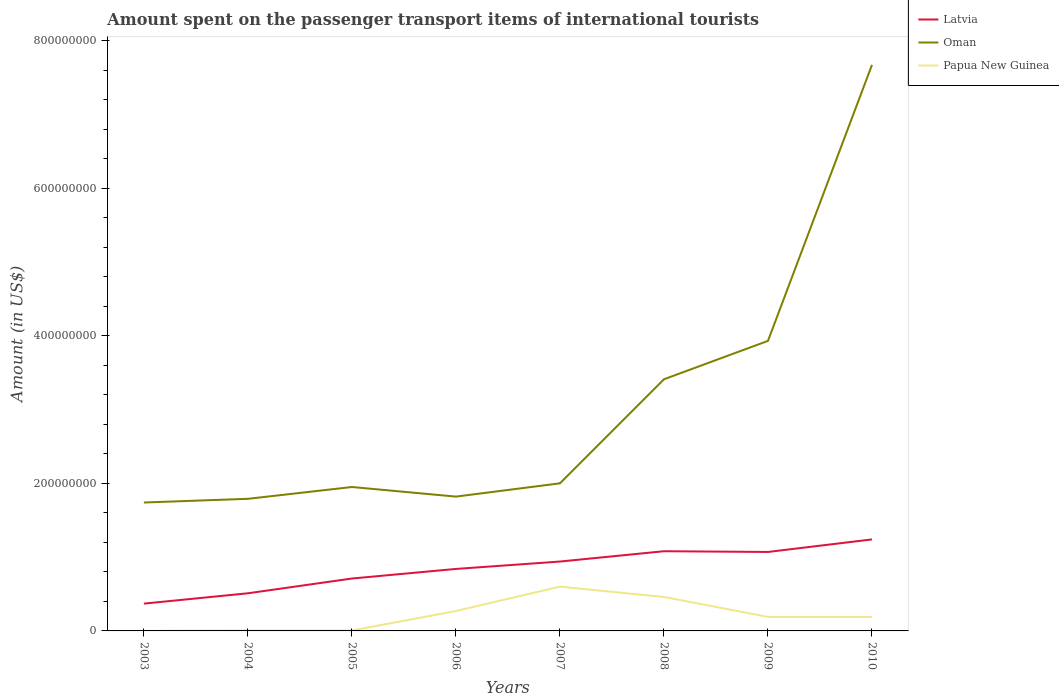Across all years, what is the maximum amount spent on the passenger transport items of international tourists in Latvia?
Offer a terse response. 3.70e+07. What is the total amount spent on the passenger transport items of international tourists in Latvia in the graph?
Provide a short and direct response. -4.30e+07. What is the difference between the highest and the second highest amount spent on the passenger transport items of international tourists in Oman?
Your answer should be very brief. 5.93e+08. Is the amount spent on the passenger transport items of international tourists in Latvia strictly greater than the amount spent on the passenger transport items of international tourists in Papua New Guinea over the years?
Your answer should be compact. No. How many lines are there?
Keep it short and to the point. 3. Where does the legend appear in the graph?
Your answer should be very brief. Top right. How are the legend labels stacked?
Give a very brief answer. Vertical. What is the title of the graph?
Your answer should be very brief. Amount spent on the passenger transport items of international tourists. Does "New Zealand" appear as one of the legend labels in the graph?
Provide a short and direct response. No. What is the label or title of the X-axis?
Ensure brevity in your answer.  Years. What is the label or title of the Y-axis?
Give a very brief answer. Amount (in US$). What is the Amount (in US$) in Latvia in 2003?
Ensure brevity in your answer.  3.70e+07. What is the Amount (in US$) of Oman in 2003?
Offer a very short reply. 1.74e+08. What is the Amount (in US$) of Latvia in 2004?
Your response must be concise. 5.10e+07. What is the Amount (in US$) of Oman in 2004?
Your answer should be compact. 1.79e+08. What is the Amount (in US$) in Papua New Guinea in 2004?
Your answer should be very brief. 7.00e+05. What is the Amount (in US$) in Latvia in 2005?
Make the answer very short. 7.10e+07. What is the Amount (in US$) in Oman in 2005?
Offer a very short reply. 1.95e+08. What is the Amount (in US$) of Latvia in 2006?
Your response must be concise. 8.40e+07. What is the Amount (in US$) in Oman in 2006?
Your answer should be compact. 1.82e+08. What is the Amount (in US$) in Papua New Guinea in 2006?
Provide a short and direct response. 2.70e+07. What is the Amount (in US$) of Latvia in 2007?
Your response must be concise. 9.40e+07. What is the Amount (in US$) in Papua New Guinea in 2007?
Give a very brief answer. 6.00e+07. What is the Amount (in US$) in Latvia in 2008?
Provide a short and direct response. 1.08e+08. What is the Amount (in US$) in Oman in 2008?
Keep it short and to the point. 3.41e+08. What is the Amount (in US$) of Papua New Guinea in 2008?
Offer a terse response. 4.60e+07. What is the Amount (in US$) in Latvia in 2009?
Give a very brief answer. 1.07e+08. What is the Amount (in US$) in Oman in 2009?
Your answer should be compact. 3.93e+08. What is the Amount (in US$) in Papua New Guinea in 2009?
Provide a short and direct response. 1.90e+07. What is the Amount (in US$) in Latvia in 2010?
Offer a very short reply. 1.24e+08. What is the Amount (in US$) in Oman in 2010?
Make the answer very short. 7.67e+08. What is the Amount (in US$) of Papua New Guinea in 2010?
Keep it short and to the point. 1.90e+07. Across all years, what is the maximum Amount (in US$) of Latvia?
Your answer should be very brief. 1.24e+08. Across all years, what is the maximum Amount (in US$) of Oman?
Keep it short and to the point. 7.67e+08. Across all years, what is the maximum Amount (in US$) in Papua New Guinea?
Provide a short and direct response. 6.00e+07. Across all years, what is the minimum Amount (in US$) in Latvia?
Make the answer very short. 3.70e+07. Across all years, what is the minimum Amount (in US$) of Oman?
Ensure brevity in your answer.  1.74e+08. What is the total Amount (in US$) in Latvia in the graph?
Your answer should be very brief. 6.76e+08. What is the total Amount (in US$) in Oman in the graph?
Provide a short and direct response. 2.43e+09. What is the total Amount (in US$) in Papua New Guinea in the graph?
Offer a very short reply. 1.72e+08. What is the difference between the Amount (in US$) of Latvia in 2003 and that in 2004?
Offer a very short reply. -1.40e+07. What is the difference between the Amount (in US$) of Oman in 2003 and that in 2004?
Keep it short and to the point. -5.00e+06. What is the difference between the Amount (in US$) in Papua New Guinea in 2003 and that in 2004?
Keep it short and to the point. -6.00e+05. What is the difference between the Amount (in US$) of Latvia in 2003 and that in 2005?
Your answer should be compact. -3.40e+07. What is the difference between the Amount (in US$) in Oman in 2003 and that in 2005?
Your response must be concise. -2.10e+07. What is the difference between the Amount (in US$) in Papua New Guinea in 2003 and that in 2005?
Offer a terse response. -5.00e+05. What is the difference between the Amount (in US$) of Latvia in 2003 and that in 2006?
Provide a succinct answer. -4.70e+07. What is the difference between the Amount (in US$) in Oman in 2003 and that in 2006?
Your response must be concise. -8.00e+06. What is the difference between the Amount (in US$) of Papua New Guinea in 2003 and that in 2006?
Ensure brevity in your answer.  -2.69e+07. What is the difference between the Amount (in US$) of Latvia in 2003 and that in 2007?
Provide a succinct answer. -5.70e+07. What is the difference between the Amount (in US$) in Oman in 2003 and that in 2007?
Provide a short and direct response. -2.60e+07. What is the difference between the Amount (in US$) in Papua New Guinea in 2003 and that in 2007?
Provide a short and direct response. -5.99e+07. What is the difference between the Amount (in US$) in Latvia in 2003 and that in 2008?
Give a very brief answer. -7.10e+07. What is the difference between the Amount (in US$) in Oman in 2003 and that in 2008?
Your response must be concise. -1.67e+08. What is the difference between the Amount (in US$) in Papua New Guinea in 2003 and that in 2008?
Your answer should be very brief. -4.59e+07. What is the difference between the Amount (in US$) in Latvia in 2003 and that in 2009?
Your answer should be compact. -7.00e+07. What is the difference between the Amount (in US$) in Oman in 2003 and that in 2009?
Ensure brevity in your answer.  -2.19e+08. What is the difference between the Amount (in US$) in Papua New Guinea in 2003 and that in 2009?
Your response must be concise. -1.89e+07. What is the difference between the Amount (in US$) in Latvia in 2003 and that in 2010?
Offer a terse response. -8.70e+07. What is the difference between the Amount (in US$) of Oman in 2003 and that in 2010?
Give a very brief answer. -5.93e+08. What is the difference between the Amount (in US$) in Papua New Guinea in 2003 and that in 2010?
Make the answer very short. -1.89e+07. What is the difference between the Amount (in US$) of Latvia in 2004 and that in 2005?
Give a very brief answer. -2.00e+07. What is the difference between the Amount (in US$) of Oman in 2004 and that in 2005?
Keep it short and to the point. -1.60e+07. What is the difference between the Amount (in US$) of Papua New Guinea in 2004 and that in 2005?
Your answer should be very brief. 1.00e+05. What is the difference between the Amount (in US$) of Latvia in 2004 and that in 2006?
Ensure brevity in your answer.  -3.30e+07. What is the difference between the Amount (in US$) of Oman in 2004 and that in 2006?
Your answer should be compact. -3.00e+06. What is the difference between the Amount (in US$) of Papua New Guinea in 2004 and that in 2006?
Your answer should be compact. -2.63e+07. What is the difference between the Amount (in US$) of Latvia in 2004 and that in 2007?
Ensure brevity in your answer.  -4.30e+07. What is the difference between the Amount (in US$) of Oman in 2004 and that in 2007?
Keep it short and to the point. -2.10e+07. What is the difference between the Amount (in US$) in Papua New Guinea in 2004 and that in 2007?
Offer a terse response. -5.93e+07. What is the difference between the Amount (in US$) of Latvia in 2004 and that in 2008?
Provide a succinct answer. -5.70e+07. What is the difference between the Amount (in US$) in Oman in 2004 and that in 2008?
Ensure brevity in your answer.  -1.62e+08. What is the difference between the Amount (in US$) in Papua New Guinea in 2004 and that in 2008?
Keep it short and to the point. -4.53e+07. What is the difference between the Amount (in US$) in Latvia in 2004 and that in 2009?
Offer a very short reply. -5.60e+07. What is the difference between the Amount (in US$) in Oman in 2004 and that in 2009?
Offer a very short reply. -2.14e+08. What is the difference between the Amount (in US$) in Papua New Guinea in 2004 and that in 2009?
Your answer should be very brief. -1.83e+07. What is the difference between the Amount (in US$) in Latvia in 2004 and that in 2010?
Provide a succinct answer. -7.30e+07. What is the difference between the Amount (in US$) in Oman in 2004 and that in 2010?
Keep it short and to the point. -5.88e+08. What is the difference between the Amount (in US$) of Papua New Guinea in 2004 and that in 2010?
Give a very brief answer. -1.83e+07. What is the difference between the Amount (in US$) of Latvia in 2005 and that in 2006?
Keep it short and to the point. -1.30e+07. What is the difference between the Amount (in US$) in Oman in 2005 and that in 2006?
Your response must be concise. 1.30e+07. What is the difference between the Amount (in US$) in Papua New Guinea in 2005 and that in 2006?
Give a very brief answer. -2.64e+07. What is the difference between the Amount (in US$) of Latvia in 2005 and that in 2007?
Provide a short and direct response. -2.30e+07. What is the difference between the Amount (in US$) in Oman in 2005 and that in 2007?
Keep it short and to the point. -5.00e+06. What is the difference between the Amount (in US$) of Papua New Guinea in 2005 and that in 2007?
Provide a short and direct response. -5.94e+07. What is the difference between the Amount (in US$) in Latvia in 2005 and that in 2008?
Give a very brief answer. -3.70e+07. What is the difference between the Amount (in US$) in Oman in 2005 and that in 2008?
Make the answer very short. -1.46e+08. What is the difference between the Amount (in US$) of Papua New Guinea in 2005 and that in 2008?
Give a very brief answer. -4.54e+07. What is the difference between the Amount (in US$) of Latvia in 2005 and that in 2009?
Offer a terse response. -3.60e+07. What is the difference between the Amount (in US$) of Oman in 2005 and that in 2009?
Make the answer very short. -1.98e+08. What is the difference between the Amount (in US$) in Papua New Guinea in 2005 and that in 2009?
Give a very brief answer. -1.84e+07. What is the difference between the Amount (in US$) of Latvia in 2005 and that in 2010?
Offer a terse response. -5.30e+07. What is the difference between the Amount (in US$) in Oman in 2005 and that in 2010?
Offer a very short reply. -5.72e+08. What is the difference between the Amount (in US$) in Papua New Guinea in 2005 and that in 2010?
Give a very brief answer. -1.84e+07. What is the difference between the Amount (in US$) of Latvia in 2006 and that in 2007?
Offer a terse response. -1.00e+07. What is the difference between the Amount (in US$) in Oman in 2006 and that in 2007?
Give a very brief answer. -1.80e+07. What is the difference between the Amount (in US$) of Papua New Guinea in 2006 and that in 2007?
Keep it short and to the point. -3.30e+07. What is the difference between the Amount (in US$) of Latvia in 2006 and that in 2008?
Make the answer very short. -2.40e+07. What is the difference between the Amount (in US$) of Oman in 2006 and that in 2008?
Provide a short and direct response. -1.59e+08. What is the difference between the Amount (in US$) in Papua New Guinea in 2006 and that in 2008?
Provide a succinct answer. -1.90e+07. What is the difference between the Amount (in US$) in Latvia in 2006 and that in 2009?
Ensure brevity in your answer.  -2.30e+07. What is the difference between the Amount (in US$) in Oman in 2006 and that in 2009?
Offer a very short reply. -2.11e+08. What is the difference between the Amount (in US$) of Papua New Guinea in 2006 and that in 2009?
Your response must be concise. 8.00e+06. What is the difference between the Amount (in US$) in Latvia in 2006 and that in 2010?
Keep it short and to the point. -4.00e+07. What is the difference between the Amount (in US$) in Oman in 2006 and that in 2010?
Make the answer very short. -5.85e+08. What is the difference between the Amount (in US$) of Latvia in 2007 and that in 2008?
Provide a short and direct response. -1.40e+07. What is the difference between the Amount (in US$) of Oman in 2007 and that in 2008?
Make the answer very short. -1.41e+08. What is the difference between the Amount (in US$) of Papua New Guinea in 2007 and that in 2008?
Provide a succinct answer. 1.40e+07. What is the difference between the Amount (in US$) in Latvia in 2007 and that in 2009?
Provide a succinct answer. -1.30e+07. What is the difference between the Amount (in US$) of Oman in 2007 and that in 2009?
Your response must be concise. -1.93e+08. What is the difference between the Amount (in US$) of Papua New Guinea in 2007 and that in 2009?
Keep it short and to the point. 4.10e+07. What is the difference between the Amount (in US$) in Latvia in 2007 and that in 2010?
Offer a terse response. -3.00e+07. What is the difference between the Amount (in US$) in Oman in 2007 and that in 2010?
Your answer should be very brief. -5.67e+08. What is the difference between the Amount (in US$) of Papua New Guinea in 2007 and that in 2010?
Give a very brief answer. 4.10e+07. What is the difference between the Amount (in US$) in Oman in 2008 and that in 2009?
Give a very brief answer. -5.20e+07. What is the difference between the Amount (in US$) of Papua New Guinea in 2008 and that in 2009?
Offer a very short reply. 2.70e+07. What is the difference between the Amount (in US$) in Latvia in 2008 and that in 2010?
Ensure brevity in your answer.  -1.60e+07. What is the difference between the Amount (in US$) in Oman in 2008 and that in 2010?
Your response must be concise. -4.26e+08. What is the difference between the Amount (in US$) in Papua New Guinea in 2008 and that in 2010?
Your response must be concise. 2.70e+07. What is the difference between the Amount (in US$) of Latvia in 2009 and that in 2010?
Keep it short and to the point. -1.70e+07. What is the difference between the Amount (in US$) of Oman in 2009 and that in 2010?
Offer a terse response. -3.74e+08. What is the difference between the Amount (in US$) of Latvia in 2003 and the Amount (in US$) of Oman in 2004?
Make the answer very short. -1.42e+08. What is the difference between the Amount (in US$) in Latvia in 2003 and the Amount (in US$) in Papua New Guinea in 2004?
Provide a succinct answer. 3.63e+07. What is the difference between the Amount (in US$) in Oman in 2003 and the Amount (in US$) in Papua New Guinea in 2004?
Your answer should be very brief. 1.73e+08. What is the difference between the Amount (in US$) of Latvia in 2003 and the Amount (in US$) of Oman in 2005?
Provide a succinct answer. -1.58e+08. What is the difference between the Amount (in US$) in Latvia in 2003 and the Amount (in US$) in Papua New Guinea in 2005?
Provide a succinct answer. 3.64e+07. What is the difference between the Amount (in US$) of Oman in 2003 and the Amount (in US$) of Papua New Guinea in 2005?
Keep it short and to the point. 1.73e+08. What is the difference between the Amount (in US$) in Latvia in 2003 and the Amount (in US$) in Oman in 2006?
Give a very brief answer. -1.45e+08. What is the difference between the Amount (in US$) in Oman in 2003 and the Amount (in US$) in Papua New Guinea in 2006?
Your answer should be compact. 1.47e+08. What is the difference between the Amount (in US$) of Latvia in 2003 and the Amount (in US$) of Oman in 2007?
Your answer should be very brief. -1.63e+08. What is the difference between the Amount (in US$) in Latvia in 2003 and the Amount (in US$) in Papua New Guinea in 2007?
Keep it short and to the point. -2.30e+07. What is the difference between the Amount (in US$) of Oman in 2003 and the Amount (in US$) of Papua New Guinea in 2007?
Provide a short and direct response. 1.14e+08. What is the difference between the Amount (in US$) of Latvia in 2003 and the Amount (in US$) of Oman in 2008?
Provide a short and direct response. -3.04e+08. What is the difference between the Amount (in US$) in Latvia in 2003 and the Amount (in US$) in Papua New Guinea in 2008?
Offer a terse response. -9.00e+06. What is the difference between the Amount (in US$) of Oman in 2003 and the Amount (in US$) of Papua New Guinea in 2008?
Offer a very short reply. 1.28e+08. What is the difference between the Amount (in US$) of Latvia in 2003 and the Amount (in US$) of Oman in 2009?
Offer a terse response. -3.56e+08. What is the difference between the Amount (in US$) in Latvia in 2003 and the Amount (in US$) in Papua New Guinea in 2009?
Your answer should be compact. 1.80e+07. What is the difference between the Amount (in US$) in Oman in 2003 and the Amount (in US$) in Papua New Guinea in 2009?
Ensure brevity in your answer.  1.55e+08. What is the difference between the Amount (in US$) of Latvia in 2003 and the Amount (in US$) of Oman in 2010?
Ensure brevity in your answer.  -7.30e+08. What is the difference between the Amount (in US$) of Latvia in 2003 and the Amount (in US$) of Papua New Guinea in 2010?
Your response must be concise. 1.80e+07. What is the difference between the Amount (in US$) in Oman in 2003 and the Amount (in US$) in Papua New Guinea in 2010?
Give a very brief answer. 1.55e+08. What is the difference between the Amount (in US$) in Latvia in 2004 and the Amount (in US$) in Oman in 2005?
Provide a short and direct response. -1.44e+08. What is the difference between the Amount (in US$) in Latvia in 2004 and the Amount (in US$) in Papua New Guinea in 2005?
Provide a succinct answer. 5.04e+07. What is the difference between the Amount (in US$) of Oman in 2004 and the Amount (in US$) of Papua New Guinea in 2005?
Ensure brevity in your answer.  1.78e+08. What is the difference between the Amount (in US$) in Latvia in 2004 and the Amount (in US$) in Oman in 2006?
Offer a terse response. -1.31e+08. What is the difference between the Amount (in US$) in Latvia in 2004 and the Amount (in US$) in Papua New Guinea in 2006?
Keep it short and to the point. 2.40e+07. What is the difference between the Amount (in US$) in Oman in 2004 and the Amount (in US$) in Papua New Guinea in 2006?
Provide a short and direct response. 1.52e+08. What is the difference between the Amount (in US$) in Latvia in 2004 and the Amount (in US$) in Oman in 2007?
Your answer should be compact. -1.49e+08. What is the difference between the Amount (in US$) in Latvia in 2004 and the Amount (in US$) in Papua New Guinea in 2007?
Provide a succinct answer. -9.00e+06. What is the difference between the Amount (in US$) of Oman in 2004 and the Amount (in US$) of Papua New Guinea in 2007?
Provide a succinct answer. 1.19e+08. What is the difference between the Amount (in US$) of Latvia in 2004 and the Amount (in US$) of Oman in 2008?
Provide a short and direct response. -2.90e+08. What is the difference between the Amount (in US$) of Oman in 2004 and the Amount (in US$) of Papua New Guinea in 2008?
Provide a succinct answer. 1.33e+08. What is the difference between the Amount (in US$) of Latvia in 2004 and the Amount (in US$) of Oman in 2009?
Offer a very short reply. -3.42e+08. What is the difference between the Amount (in US$) in Latvia in 2004 and the Amount (in US$) in Papua New Guinea in 2009?
Keep it short and to the point. 3.20e+07. What is the difference between the Amount (in US$) in Oman in 2004 and the Amount (in US$) in Papua New Guinea in 2009?
Your answer should be very brief. 1.60e+08. What is the difference between the Amount (in US$) in Latvia in 2004 and the Amount (in US$) in Oman in 2010?
Offer a very short reply. -7.16e+08. What is the difference between the Amount (in US$) in Latvia in 2004 and the Amount (in US$) in Papua New Guinea in 2010?
Your answer should be very brief. 3.20e+07. What is the difference between the Amount (in US$) of Oman in 2004 and the Amount (in US$) of Papua New Guinea in 2010?
Offer a very short reply. 1.60e+08. What is the difference between the Amount (in US$) of Latvia in 2005 and the Amount (in US$) of Oman in 2006?
Offer a very short reply. -1.11e+08. What is the difference between the Amount (in US$) of Latvia in 2005 and the Amount (in US$) of Papua New Guinea in 2006?
Provide a short and direct response. 4.40e+07. What is the difference between the Amount (in US$) in Oman in 2005 and the Amount (in US$) in Papua New Guinea in 2006?
Provide a short and direct response. 1.68e+08. What is the difference between the Amount (in US$) in Latvia in 2005 and the Amount (in US$) in Oman in 2007?
Your answer should be very brief. -1.29e+08. What is the difference between the Amount (in US$) of Latvia in 2005 and the Amount (in US$) of Papua New Guinea in 2007?
Your answer should be very brief. 1.10e+07. What is the difference between the Amount (in US$) of Oman in 2005 and the Amount (in US$) of Papua New Guinea in 2007?
Keep it short and to the point. 1.35e+08. What is the difference between the Amount (in US$) of Latvia in 2005 and the Amount (in US$) of Oman in 2008?
Make the answer very short. -2.70e+08. What is the difference between the Amount (in US$) in Latvia in 2005 and the Amount (in US$) in Papua New Guinea in 2008?
Offer a terse response. 2.50e+07. What is the difference between the Amount (in US$) of Oman in 2005 and the Amount (in US$) of Papua New Guinea in 2008?
Make the answer very short. 1.49e+08. What is the difference between the Amount (in US$) in Latvia in 2005 and the Amount (in US$) in Oman in 2009?
Ensure brevity in your answer.  -3.22e+08. What is the difference between the Amount (in US$) of Latvia in 2005 and the Amount (in US$) of Papua New Guinea in 2009?
Make the answer very short. 5.20e+07. What is the difference between the Amount (in US$) of Oman in 2005 and the Amount (in US$) of Papua New Guinea in 2009?
Provide a succinct answer. 1.76e+08. What is the difference between the Amount (in US$) in Latvia in 2005 and the Amount (in US$) in Oman in 2010?
Give a very brief answer. -6.96e+08. What is the difference between the Amount (in US$) of Latvia in 2005 and the Amount (in US$) of Papua New Guinea in 2010?
Provide a succinct answer. 5.20e+07. What is the difference between the Amount (in US$) in Oman in 2005 and the Amount (in US$) in Papua New Guinea in 2010?
Offer a terse response. 1.76e+08. What is the difference between the Amount (in US$) in Latvia in 2006 and the Amount (in US$) in Oman in 2007?
Your response must be concise. -1.16e+08. What is the difference between the Amount (in US$) of Latvia in 2006 and the Amount (in US$) of Papua New Guinea in 2007?
Offer a very short reply. 2.40e+07. What is the difference between the Amount (in US$) of Oman in 2006 and the Amount (in US$) of Papua New Guinea in 2007?
Ensure brevity in your answer.  1.22e+08. What is the difference between the Amount (in US$) of Latvia in 2006 and the Amount (in US$) of Oman in 2008?
Ensure brevity in your answer.  -2.57e+08. What is the difference between the Amount (in US$) of Latvia in 2006 and the Amount (in US$) of Papua New Guinea in 2008?
Keep it short and to the point. 3.80e+07. What is the difference between the Amount (in US$) in Oman in 2006 and the Amount (in US$) in Papua New Guinea in 2008?
Provide a succinct answer. 1.36e+08. What is the difference between the Amount (in US$) in Latvia in 2006 and the Amount (in US$) in Oman in 2009?
Your answer should be compact. -3.09e+08. What is the difference between the Amount (in US$) in Latvia in 2006 and the Amount (in US$) in Papua New Guinea in 2009?
Make the answer very short. 6.50e+07. What is the difference between the Amount (in US$) of Oman in 2006 and the Amount (in US$) of Papua New Guinea in 2009?
Ensure brevity in your answer.  1.63e+08. What is the difference between the Amount (in US$) in Latvia in 2006 and the Amount (in US$) in Oman in 2010?
Keep it short and to the point. -6.83e+08. What is the difference between the Amount (in US$) in Latvia in 2006 and the Amount (in US$) in Papua New Guinea in 2010?
Give a very brief answer. 6.50e+07. What is the difference between the Amount (in US$) in Oman in 2006 and the Amount (in US$) in Papua New Guinea in 2010?
Offer a very short reply. 1.63e+08. What is the difference between the Amount (in US$) of Latvia in 2007 and the Amount (in US$) of Oman in 2008?
Your answer should be very brief. -2.47e+08. What is the difference between the Amount (in US$) of Latvia in 2007 and the Amount (in US$) of Papua New Guinea in 2008?
Offer a very short reply. 4.80e+07. What is the difference between the Amount (in US$) of Oman in 2007 and the Amount (in US$) of Papua New Guinea in 2008?
Your answer should be compact. 1.54e+08. What is the difference between the Amount (in US$) in Latvia in 2007 and the Amount (in US$) in Oman in 2009?
Provide a short and direct response. -2.99e+08. What is the difference between the Amount (in US$) in Latvia in 2007 and the Amount (in US$) in Papua New Guinea in 2009?
Ensure brevity in your answer.  7.50e+07. What is the difference between the Amount (in US$) in Oman in 2007 and the Amount (in US$) in Papua New Guinea in 2009?
Your response must be concise. 1.81e+08. What is the difference between the Amount (in US$) in Latvia in 2007 and the Amount (in US$) in Oman in 2010?
Provide a succinct answer. -6.73e+08. What is the difference between the Amount (in US$) in Latvia in 2007 and the Amount (in US$) in Papua New Guinea in 2010?
Provide a succinct answer. 7.50e+07. What is the difference between the Amount (in US$) in Oman in 2007 and the Amount (in US$) in Papua New Guinea in 2010?
Offer a very short reply. 1.81e+08. What is the difference between the Amount (in US$) in Latvia in 2008 and the Amount (in US$) in Oman in 2009?
Your response must be concise. -2.85e+08. What is the difference between the Amount (in US$) in Latvia in 2008 and the Amount (in US$) in Papua New Guinea in 2009?
Keep it short and to the point. 8.90e+07. What is the difference between the Amount (in US$) in Oman in 2008 and the Amount (in US$) in Papua New Guinea in 2009?
Offer a terse response. 3.22e+08. What is the difference between the Amount (in US$) of Latvia in 2008 and the Amount (in US$) of Oman in 2010?
Your response must be concise. -6.59e+08. What is the difference between the Amount (in US$) in Latvia in 2008 and the Amount (in US$) in Papua New Guinea in 2010?
Ensure brevity in your answer.  8.90e+07. What is the difference between the Amount (in US$) of Oman in 2008 and the Amount (in US$) of Papua New Guinea in 2010?
Ensure brevity in your answer.  3.22e+08. What is the difference between the Amount (in US$) in Latvia in 2009 and the Amount (in US$) in Oman in 2010?
Provide a succinct answer. -6.60e+08. What is the difference between the Amount (in US$) of Latvia in 2009 and the Amount (in US$) of Papua New Guinea in 2010?
Provide a succinct answer. 8.80e+07. What is the difference between the Amount (in US$) of Oman in 2009 and the Amount (in US$) of Papua New Guinea in 2010?
Offer a terse response. 3.74e+08. What is the average Amount (in US$) of Latvia per year?
Give a very brief answer. 8.45e+07. What is the average Amount (in US$) of Oman per year?
Your answer should be compact. 3.04e+08. What is the average Amount (in US$) of Papua New Guinea per year?
Offer a terse response. 2.16e+07. In the year 2003, what is the difference between the Amount (in US$) in Latvia and Amount (in US$) in Oman?
Your answer should be very brief. -1.37e+08. In the year 2003, what is the difference between the Amount (in US$) of Latvia and Amount (in US$) of Papua New Guinea?
Offer a terse response. 3.69e+07. In the year 2003, what is the difference between the Amount (in US$) in Oman and Amount (in US$) in Papua New Guinea?
Offer a terse response. 1.74e+08. In the year 2004, what is the difference between the Amount (in US$) of Latvia and Amount (in US$) of Oman?
Keep it short and to the point. -1.28e+08. In the year 2004, what is the difference between the Amount (in US$) in Latvia and Amount (in US$) in Papua New Guinea?
Offer a very short reply. 5.03e+07. In the year 2004, what is the difference between the Amount (in US$) in Oman and Amount (in US$) in Papua New Guinea?
Keep it short and to the point. 1.78e+08. In the year 2005, what is the difference between the Amount (in US$) in Latvia and Amount (in US$) in Oman?
Your answer should be compact. -1.24e+08. In the year 2005, what is the difference between the Amount (in US$) of Latvia and Amount (in US$) of Papua New Guinea?
Make the answer very short. 7.04e+07. In the year 2005, what is the difference between the Amount (in US$) of Oman and Amount (in US$) of Papua New Guinea?
Provide a short and direct response. 1.94e+08. In the year 2006, what is the difference between the Amount (in US$) in Latvia and Amount (in US$) in Oman?
Offer a terse response. -9.80e+07. In the year 2006, what is the difference between the Amount (in US$) of Latvia and Amount (in US$) of Papua New Guinea?
Provide a short and direct response. 5.70e+07. In the year 2006, what is the difference between the Amount (in US$) of Oman and Amount (in US$) of Papua New Guinea?
Your answer should be very brief. 1.55e+08. In the year 2007, what is the difference between the Amount (in US$) in Latvia and Amount (in US$) in Oman?
Your answer should be very brief. -1.06e+08. In the year 2007, what is the difference between the Amount (in US$) in Latvia and Amount (in US$) in Papua New Guinea?
Give a very brief answer. 3.40e+07. In the year 2007, what is the difference between the Amount (in US$) in Oman and Amount (in US$) in Papua New Guinea?
Provide a short and direct response. 1.40e+08. In the year 2008, what is the difference between the Amount (in US$) in Latvia and Amount (in US$) in Oman?
Your answer should be compact. -2.33e+08. In the year 2008, what is the difference between the Amount (in US$) in Latvia and Amount (in US$) in Papua New Guinea?
Keep it short and to the point. 6.20e+07. In the year 2008, what is the difference between the Amount (in US$) of Oman and Amount (in US$) of Papua New Guinea?
Provide a short and direct response. 2.95e+08. In the year 2009, what is the difference between the Amount (in US$) in Latvia and Amount (in US$) in Oman?
Give a very brief answer. -2.86e+08. In the year 2009, what is the difference between the Amount (in US$) in Latvia and Amount (in US$) in Papua New Guinea?
Provide a succinct answer. 8.80e+07. In the year 2009, what is the difference between the Amount (in US$) in Oman and Amount (in US$) in Papua New Guinea?
Provide a succinct answer. 3.74e+08. In the year 2010, what is the difference between the Amount (in US$) in Latvia and Amount (in US$) in Oman?
Your answer should be compact. -6.43e+08. In the year 2010, what is the difference between the Amount (in US$) in Latvia and Amount (in US$) in Papua New Guinea?
Provide a succinct answer. 1.05e+08. In the year 2010, what is the difference between the Amount (in US$) in Oman and Amount (in US$) in Papua New Guinea?
Your answer should be compact. 7.48e+08. What is the ratio of the Amount (in US$) of Latvia in 2003 to that in 2004?
Your answer should be compact. 0.73. What is the ratio of the Amount (in US$) of Oman in 2003 to that in 2004?
Offer a terse response. 0.97. What is the ratio of the Amount (in US$) in Papua New Guinea in 2003 to that in 2004?
Offer a terse response. 0.14. What is the ratio of the Amount (in US$) in Latvia in 2003 to that in 2005?
Offer a very short reply. 0.52. What is the ratio of the Amount (in US$) of Oman in 2003 to that in 2005?
Your answer should be compact. 0.89. What is the ratio of the Amount (in US$) of Latvia in 2003 to that in 2006?
Offer a terse response. 0.44. What is the ratio of the Amount (in US$) of Oman in 2003 to that in 2006?
Give a very brief answer. 0.96. What is the ratio of the Amount (in US$) in Papua New Guinea in 2003 to that in 2006?
Give a very brief answer. 0. What is the ratio of the Amount (in US$) of Latvia in 2003 to that in 2007?
Your answer should be very brief. 0.39. What is the ratio of the Amount (in US$) in Oman in 2003 to that in 2007?
Your response must be concise. 0.87. What is the ratio of the Amount (in US$) of Papua New Guinea in 2003 to that in 2007?
Your answer should be compact. 0. What is the ratio of the Amount (in US$) of Latvia in 2003 to that in 2008?
Give a very brief answer. 0.34. What is the ratio of the Amount (in US$) of Oman in 2003 to that in 2008?
Your answer should be very brief. 0.51. What is the ratio of the Amount (in US$) in Papua New Guinea in 2003 to that in 2008?
Offer a terse response. 0. What is the ratio of the Amount (in US$) in Latvia in 2003 to that in 2009?
Ensure brevity in your answer.  0.35. What is the ratio of the Amount (in US$) of Oman in 2003 to that in 2009?
Ensure brevity in your answer.  0.44. What is the ratio of the Amount (in US$) of Papua New Guinea in 2003 to that in 2009?
Your answer should be very brief. 0.01. What is the ratio of the Amount (in US$) of Latvia in 2003 to that in 2010?
Ensure brevity in your answer.  0.3. What is the ratio of the Amount (in US$) in Oman in 2003 to that in 2010?
Your response must be concise. 0.23. What is the ratio of the Amount (in US$) of Papua New Guinea in 2003 to that in 2010?
Make the answer very short. 0.01. What is the ratio of the Amount (in US$) of Latvia in 2004 to that in 2005?
Your answer should be compact. 0.72. What is the ratio of the Amount (in US$) in Oman in 2004 to that in 2005?
Give a very brief answer. 0.92. What is the ratio of the Amount (in US$) in Latvia in 2004 to that in 2006?
Provide a short and direct response. 0.61. What is the ratio of the Amount (in US$) in Oman in 2004 to that in 2006?
Your response must be concise. 0.98. What is the ratio of the Amount (in US$) in Papua New Guinea in 2004 to that in 2006?
Keep it short and to the point. 0.03. What is the ratio of the Amount (in US$) in Latvia in 2004 to that in 2007?
Make the answer very short. 0.54. What is the ratio of the Amount (in US$) in Oman in 2004 to that in 2007?
Your answer should be very brief. 0.9. What is the ratio of the Amount (in US$) in Papua New Guinea in 2004 to that in 2007?
Offer a very short reply. 0.01. What is the ratio of the Amount (in US$) of Latvia in 2004 to that in 2008?
Give a very brief answer. 0.47. What is the ratio of the Amount (in US$) of Oman in 2004 to that in 2008?
Provide a succinct answer. 0.52. What is the ratio of the Amount (in US$) in Papua New Guinea in 2004 to that in 2008?
Offer a very short reply. 0.02. What is the ratio of the Amount (in US$) of Latvia in 2004 to that in 2009?
Your answer should be very brief. 0.48. What is the ratio of the Amount (in US$) in Oman in 2004 to that in 2009?
Keep it short and to the point. 0.46. What is the ratio of the Amount (in US$) of Papua New Guinea in 2004 to that in 2009?
Make the answer very short. 0.04. What is the ratio of the Amount (in US$) of Latvia in 2004 to that in 2010?
Provide a succinct answer. 0.41. What is the ratio of the Amount (in US$) of Oman in 2004 to that in 2010?
Offer a very short reply. 0.23. What is the ratio of the Amount (in US$) in Papua New Guinea in 2004 to that in 2010?
Keep it short and to the point. 0.04. What is the ratio of the Amount (in US$) in Latvia in 2005 to that in 2006?
Your response must be concise. 0.85. What is the ratio of the Amount (in US$) in Oman in 2005 to that in 2006?
Provide a short and direct response. 1.07. What is the ratio of the Amount (in US$) in Papua New Guinea in 2005 to that in 2006?
Give a very brief answer. 0.02. What is the ratio of the Amount (in US$) of Latvia in 2005 to that in 2007?
Offer a terse response. 0.76. What is the ratio of the Amount (in US$) of Oman in 2005 to that in 2007?
Give a very brief answer. 0.97. What is the ratio of the Amount (in US$) in Papua New Guinea in 2005 to that in 2007?
Your answer should be compact. 0.01. What is the ratio of the Amount (in US$) in Latvia in 2005 to that in 2008?
Offer a very short reply. 0.66. What is the ratio of the Amount (in US$) of Oman in 2005 to that in 2008?
Your answer should be very brief. 0.57. What is the ratio of the Amount (in US$) of Papua New Guinea in 2005 to that in 2008?
Provide a succinct answer. 0.01. What is the ratio of the Amount (in US$) in Latvia in 2005 to that in 2009?
Ensure brevity in your answer.  0.66. What is the ratio of the Amount (in US$) of Oman in 2005 to that in 2009?
Make the answer very short. 0.5. What is the ratio of the Amount (in US$) of Papua New Guinea in 2005 to that in 2009?
Make the answer very short. 0.03. What is the ratio of the Amount (in US$) of Latvia in 2005 to that in 2010?
Your answer should be compact. 0.57. What is the ratio of the Amount (in US$) of Oman in 2005 to that in 2010?
Give a very brief answer. 0.25. What is the ratio of the Amount (in US$) of Papua New Guinea in 2005 to that in 2010?
Provide a short and direct response. 0.03. What is the ratio of the Amount (in US$) of Latvia in 2006 to that in 2007?
Make the answer very short. 0.89. What is the ratio of the Amount (in US$) in Oman in 2006 to that in 2007?
Offer a terse response. 0.91. What is the ratio of the Amount (in US$) in Papua New Guinea in 2006 to that in 2007?
Keep it short and to the point. 0.45. What is the ratio of the Amount (in US$) in Latvia in 2006 to that in 2008?
Give a very brief answer. 0.78. What is the ratio of the Amount (in US$) in Oman in 2006 to that in 2008?
Offer a very short reply. 0.53. What is the ratio of the Amount (in US$) in Papua New Guinea in 2006 to that in 2008?
Offer a very short reply. 0.59. What is the ratio of the Amount (in US$) in Latvia in 2006 to that in 2009?
Provide a short and direct response. 0.79. What is the ratio of the Amount (in US$) of Oman in 2006 to that in 2009?
Offer a terse response. 0.46. What is the ratio of the Amount (in US$) in Papua New Guinea in 2006 to that in 2009?
Offer a terse response. 1.42. What is the ratio of the Amount (in US$) in Latvia in 2006 to that in 2010?
Keep it short and to the point. 0.68. What is the ratio of the Amount (in US$) of Oman in 2006 to that in 2010?
Offer a terse response. 0.24. What is the ratio of the Amount (in US$) in Papua New Guinea in 2006 to that in 2010?
Give a very brief answer. 1.42. What is the ratio of the Amount (in US$) in Latvia in 2007 to that in 2008?
Provide a succinct answer. 0.87. What is the ratio of the Amount (in US$) in Oman in 2007 to that in 2008?
Offer a terse response. 0.59. What is the ratio of the Amount (in US$) in Papua New Guinea in 2007 to that in 2008?
Your answer should be very brief. 1.3. What is the ratio of the Amount (in US$) in Latvia in 2007 to that in 2009?
Your answer should be very brief. 0.88. What is the ratio of the Amount (in US$) in Oman in 2007 to that in 2009?
Provide a succinct answer. 0.51. What is the ratio of the Amount (in US$) in Papua New Guinea in 2007 to that in 2009?
Your answer should be very brief. 3.16. What is the ratio of the Amount (in US$) of Latvia in 2007 to that in 2010?
Give a very brief answer. 0.76. What is the ratio of the Amount (in US$) of Oman in 2007 to that in 2010?
Make the answer very short. 0.26. What is the ratio of the Amount (in US$) of Papua New Guinea in 2007 to that in 2010?
Your response must be concise. 3.16. What is the ratio of the Amount (in US$) of Latvia in 2008 to that in 2009?
Provide a short and direct response. 1.01. What is the ratio of the Amount (in US$) in Oman in 2008 to that in 2009?
Your answer should be very brief. 0.87. What is the ratio of the Amount (in US$) of Papua New Guinea in 2008 to that in 2009?
Provide a short and direct response. 2.42. What is the ratio of the Amount (in US$) of Latvia in 2008 to that in 2010?
Give a very brief answer. 0.87. What is the ratio of the Amount (in US$) of Oman in 2008 to that in 2010?
Provide a succinct answer. 0.44. What is the ratio of the Amount (in US$) of Papua New Guinea in 2008 to that in 2010?
Make the answer very short. 2.42. What is the ratio of the Amount (in US$) in Latvia in 2009 to that in 2010?
Offer a terse response. 0.86. What is the ratio of the Amount (in US$) in Oman in 2009 to that in 2010?
Your response must be concise. 0.51. What is the ratio of the Amount (in US$) in Papua New Guinea in 2009 to that in 2010?
Your answer should be compact. 1. What is the difference between the highest and the second highest Amount (in US$) in Latvia?
Your answer should be very brief. 1.60e+07. What is the difference between the highest and the second highest Amount (in US$) of Oman?
Provide a succinct answer. 3.74e+08. What is the difference between the highest and the second highest Amount (in US$) in Papua New Guinea?
Offer a terse response. 1.40e+07. What is the difference between the highest and the lowest Amount (in US$) in Latvia?
Your response must be concise. 8.70e+07. What is the difference between the highest and the lowest Amount (in US$) of Oman?
Your response must be concise. 5.93e+08. What is the difference between the highest and the lowest Amount (in US$) of Papua New Guinea?
Offer a very short reply. 5.99e+07. 